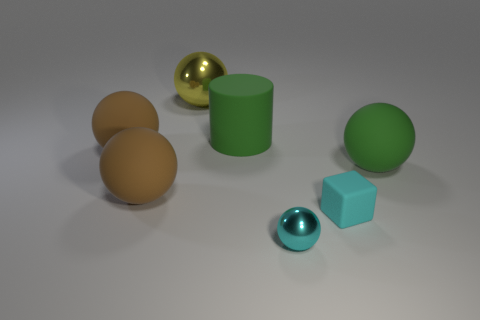Subtract 2 balls. How many balls are left? 3 Subtract all cyan spheres. How many spheres are left? 4 Subtract all yellow balls. How many balls are left? 4 Subtract all blue spheres. Subtract all purple blocks. How many spheres are left? 5 Add 2 cyan rubber cylinders. How many objects exist? 9 Subtract all cylinders. How many objects are left? 6 Subtract 0 cyan cylinders. How many objects are left? 7 Subtract all yellow things. Subtract all cylinders. How many objects are left? 5 Add 6 cylinders. How many cylinders are left? 7 Add 7 green matte cylinders. How many green matte cylinders exist? 8 